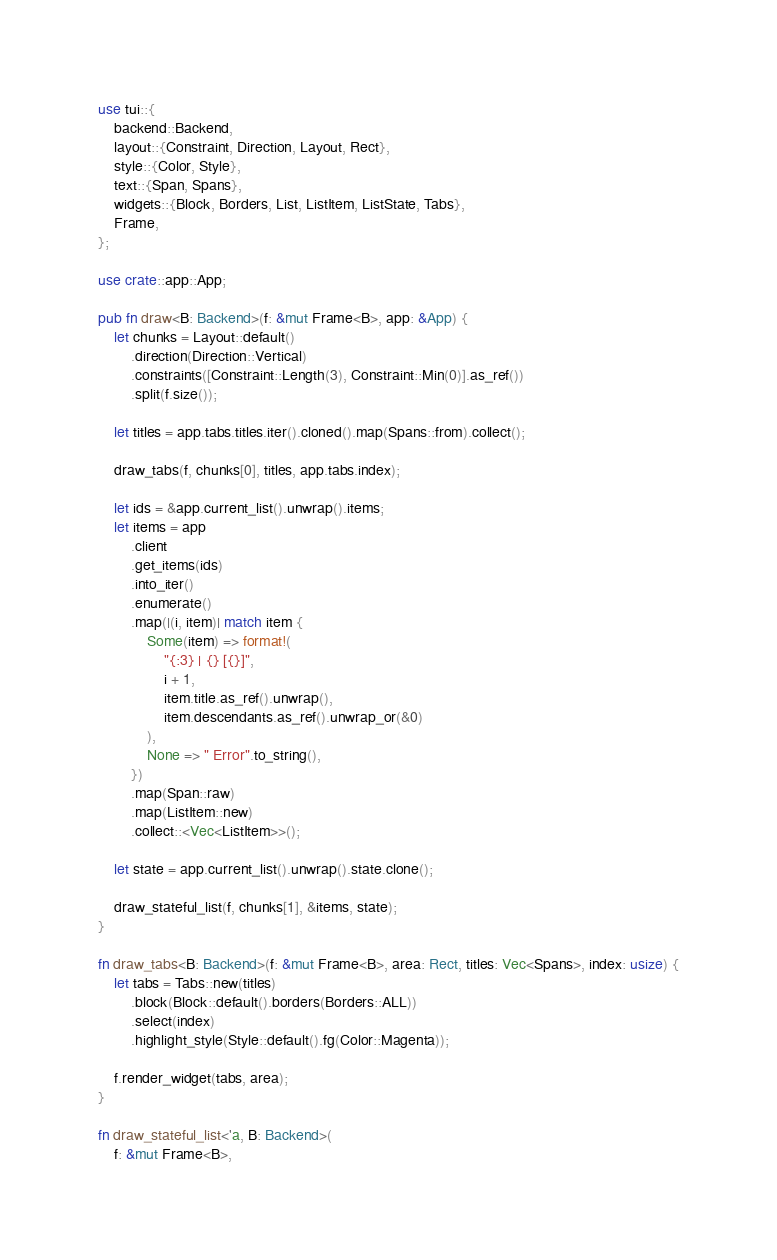<code> <loc_0><loc_0><loc_500><loc_500><_Rust_>use tui::{
    backend::Backend,
    layout::{Constraint, Direction, Layout, Rect},
    style::{Color, Style},
    text::{Span, Spans},
    widgets::{Block, Borders, List, ListItem, ListState, Tabs},
    Frame,
};

use crate::app::App;

pub fn draw<B: Backend>(f: &mut Frame<B>, app: &App) {
    let chunks = Layout::default()
        .direction(Direction::Vertical)
        .constraints([Constraint::Length(3), Constraint::Min(0)].as_ref())
        .split(f.size());

    let titles = app.tabs.titles.iter().cloned().map(Spans::from).collect();

    draw_tabs(f, chunks[0], titles, app.tabs.index);

    let ids = &app.current_list().unwrap().items;
    let items = app
        .client
        .get_items(ids)
        .into_iter()
        .enumerate()
        .map(|(i, item)| match item {
            Some(item) => format!(
                "{:3} | {} [{}]",
                i + 1,
                item.title.as_ref().unwrap(),
                item.descendants.as_ref().unwrap_or(&0)
            ),
            None => " Error".to_string(),
        })
        .map(Span::raw)
        .map(ListItem::new)
        .collect::<Vec<ListItem>>();

    let state = app.current_list().unwrap().state.clone();

    draw_stateful_list(f, chunks[1], &items, state);
}

fn draw_tabs<B: Backend>(f: &mut Frame<B>, area: Rect, titles: Vec<Spans>, index: usize) {
    let tabs = Tabs::new(titles)
        .block(Block::default().borders(Borders::ALL))
        .select(index)
        .highlight_style(Style::default().fg(Color::Magenta));

    f.render_widget(tabs, area);
}

fn draw_stateful_list<'a, B: Backend>(
    f: &mut Frame<B>,</code> 